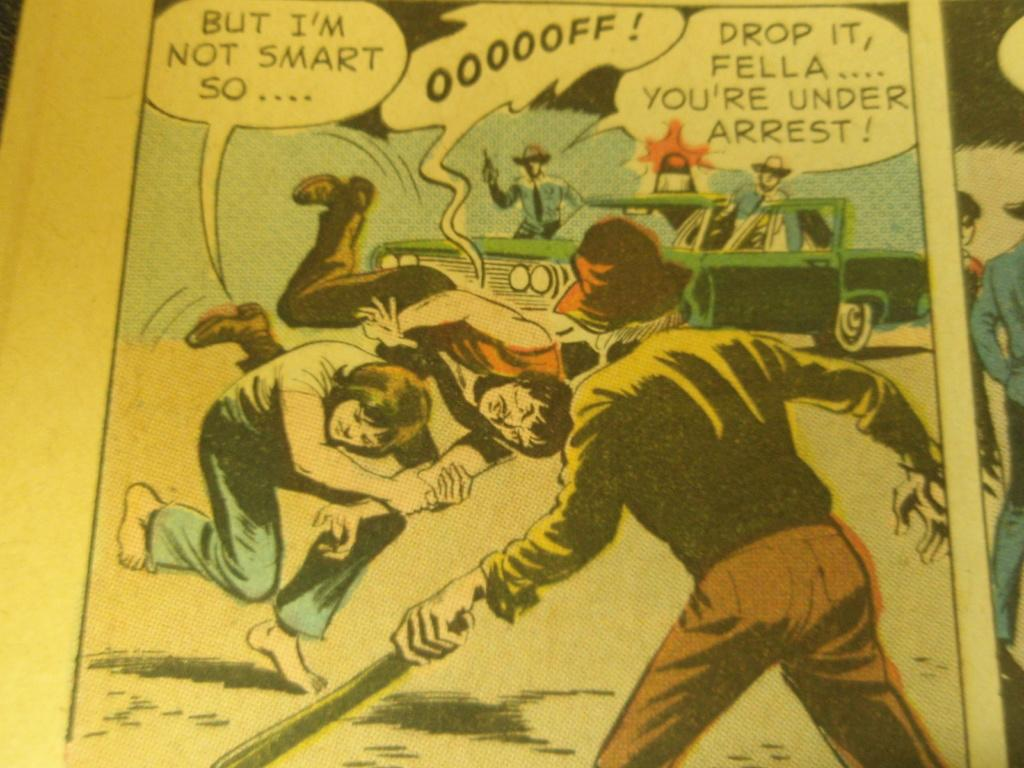<image>
Render a clear and concise summary of the photo. the word arrest is in a bubble above the comic characters 